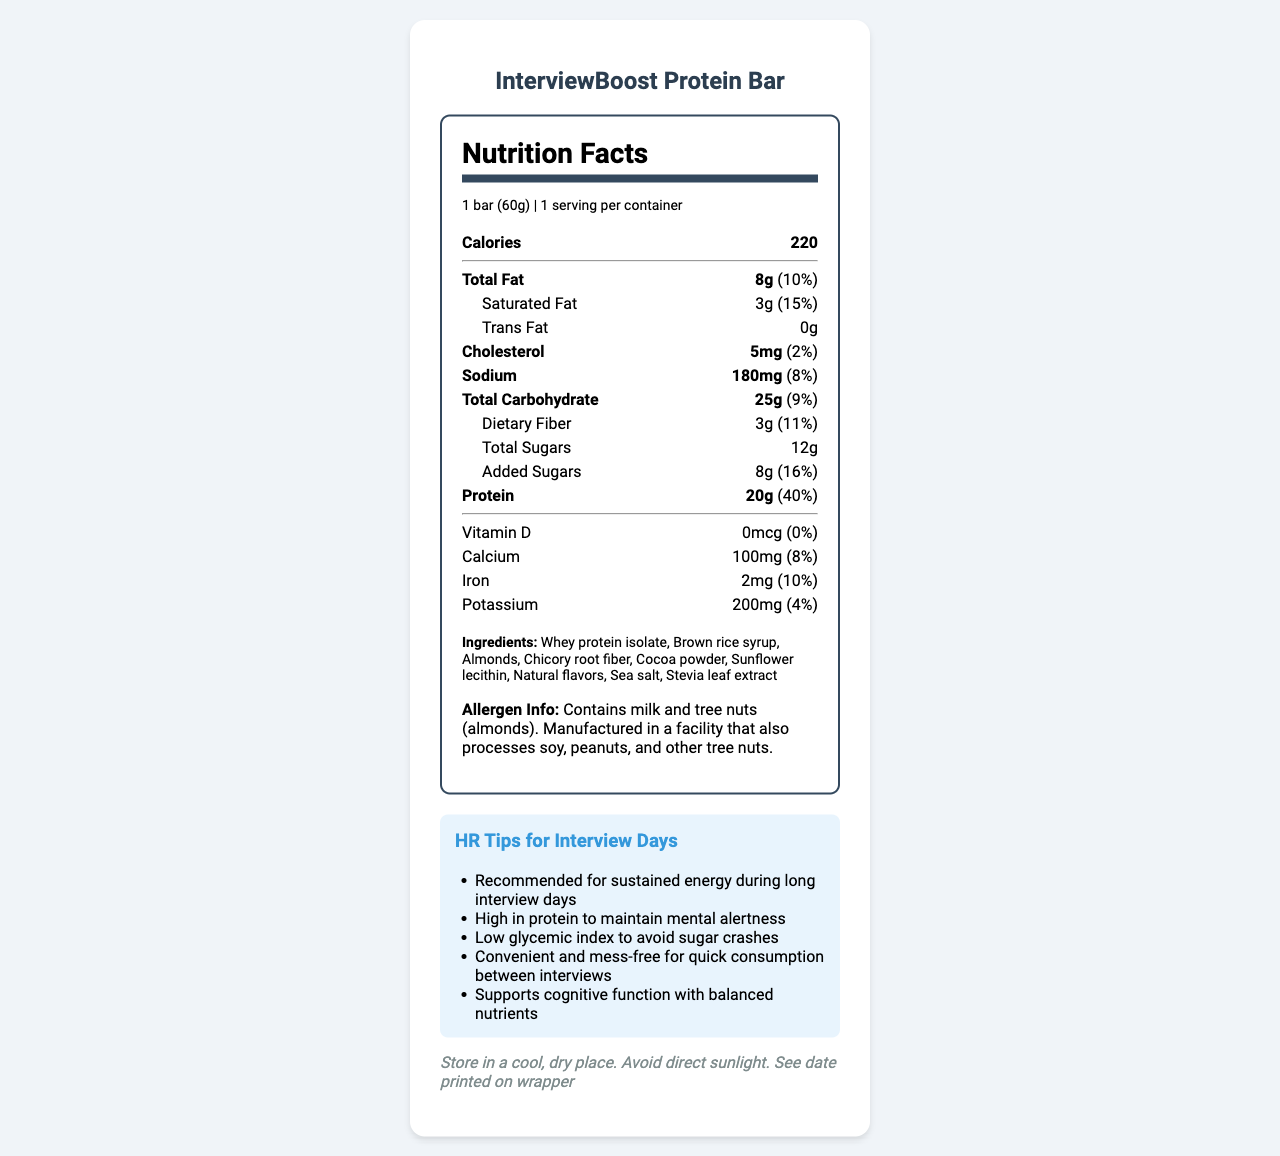what is the serving size of the InterviewBoost Protein Bar? The serving size is directly stated at the beginning of the document under serving information.
Answer: 1 bar (60g) how many grams of protein does one serving of the InterviewBoost Protein Bar contain? The amount of protein per serving is specified in the nutrient section, where it is noted as 20g.
Answer: 20g what is the daily value percentage of protein for one serving? The daily value percentage for protein is shown next to the protein amount, which is 40%.
Answer: 40% name three ingredients found in the InterviewBoost Protein Bar. The ingredients list contains these three (and more) ingredients, which are stated in the document.
Answer: Whey protein isolate, Brown rice syrup, Almonds which nutrient has the highest daily value percentage in one serving? The daily value percentage for protein is 40%, which is the highest among all listed nutrients.
Answer: Protein what is the total amount of sugar, including added sugars, in one serving? The document states the total sugars as 12g, and below it, the added sugars are detailed (8g), but the total amount is still 12g.
Answer: 12g identify two allergens mentioned in the allergen information. A. Milk and Tree nuts B. Wheat and Soy C. Peanuts and Fish The allergen information specifies that the product contains milk and tree nuts (almonds).
Answer: A. Milk and Tree nuts which nutrient has the lowest daily value percentage? A. Calcium B. Vitamin D C. Sodium D. Iron Vitamin D has a daily value percentage of 0%, the lowest among all nutrients listed.
Answer: B. Vitamin D is the InterviewBoost Protein Bar suitable for someone with a peanut allergy? The allergen information indicates that the bar is manufactured in a facility that processes peanuts.
Answer: No summarize the main benefits of the InterviewBoost Protein Bar as suggested in the HR tips. The HR tips focus on the bar's advantages during long interview days, including energy sustainment, mental alertness, avoidance of sugar crashes, convenience, and cognitive support.
Answer: The InterviewBoost Protein Bar is recommended for sustained energy during long interview days, helping maintain mental alertness with high protein content. It has a low glycemic index to avoid sugar crashes and offers convenience for quick consumption between interviews, supporting cognitive function with balanced nutrients. how long can you store the InterviewBoost Protein Bar before it expires? The document suggests checking the date printed on the wrapper for the best before date, which is not shown in the visible document.
Answer: Cannot be determined what is the daily value percentage of saturated fat in one serving? The daily value percentage for saturated fat is provided next to its amount, which is 15%.
Answer: 15% where should you store the InterviewBoost Protein Bar to maintain its quality? The storage instructions indicate to keep the bar in a cool, dry place and to avoid direct sunlight.
Answer: In a cool, dry place; avoid direct sunlight what is the total fat amount in one serving? The total fat amount per serving is specified as 8g in the nutrition facts section.
Answer: 8g how much dietary fiber is included in one serving? The amount of dietary fiber per serving is noted as 3g in the document.
Answer: 3g describe the allergen information for the InterviewBoost Protein Bar. The allergen information specifies the presence of milk and almonds and mentions potential cross-contamination with soy, peanuts, and other tree nuts.
Answer: The protein bar contains milk and tree nuts (almonds). It is manufactured in a facility that also processes soy, peanuts, and other tree nuts. 